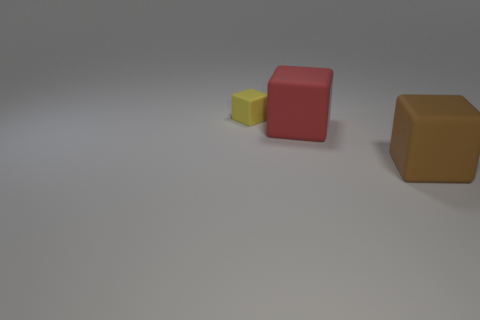There is a yellow object that is made of the same material as the big brown cube; what is its size?
Give a very brief answer. Small. Is the number of big red blocks greater than the number of cyan matte objects?
Your response must be concise. Yes. There is a object to the left of the red rubber thing; is its size the same as the large brown matte block?
Keep it short and to the point. No. How many cubes are either tiny purple objects or small yellow things?
Offer a terse response. 1. Is the number of large red rubber things less than the number of big blue matte things?
Your answer should be compact. No. There is a yellow cube behind the rubber thing on the right side of the large matte cube on the left side of the big brown matte object; what size is it?
Your response must be concise. Small. What number of other things are there of the same color as the tiny matte block?
Your response must be concise. 0. How many things are either big matte objects or red rubber blocks?
Give a very brief answer. 2. There is a object that is to the right of the large red cube; what is its color?
Keep it short and to the point. Brown. Is the number of yellow cubes that are right of the red rubber thing less than the number of big brown things?
Your answer should be compact. Yes. 